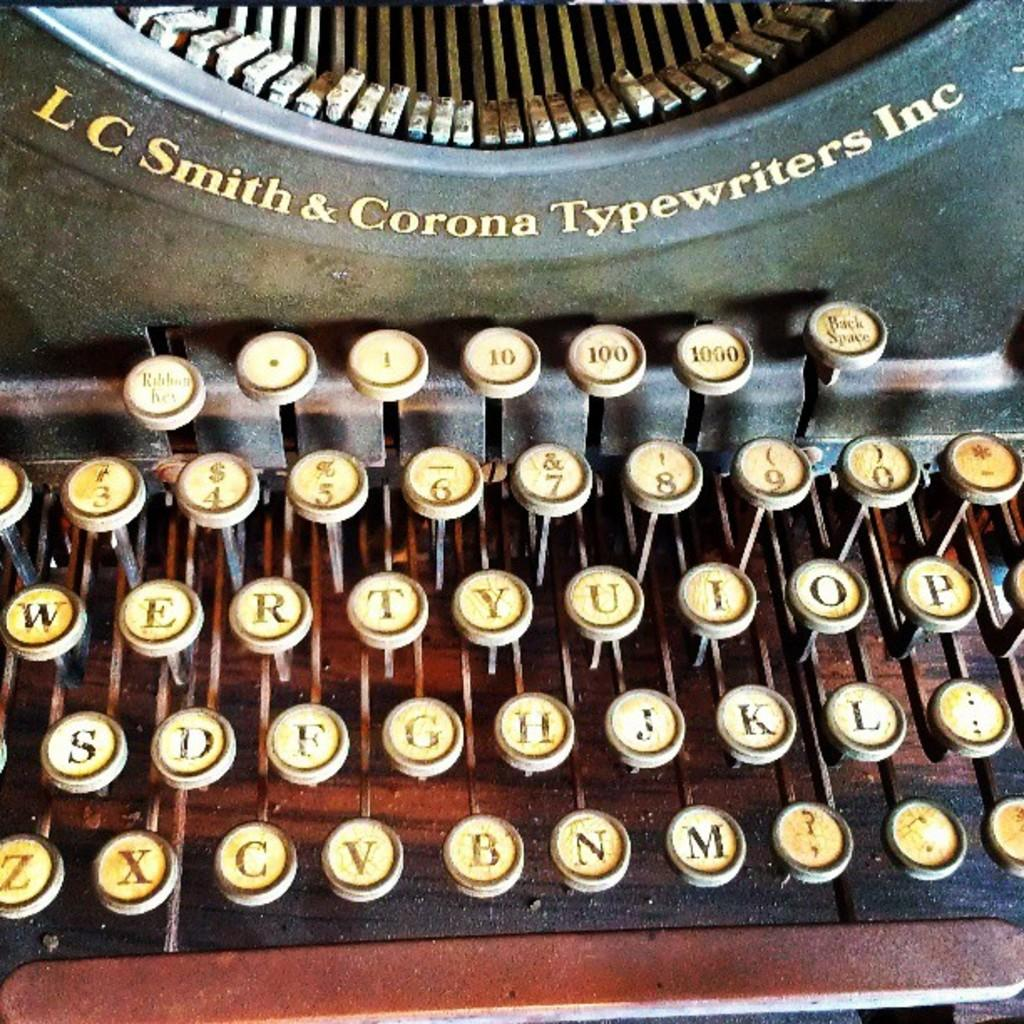<image>
Relay a brief, clear account of the picture shown. An old time typewriter has the company name LC Smith & Corona Typewriters Inc on it in raised letters. 